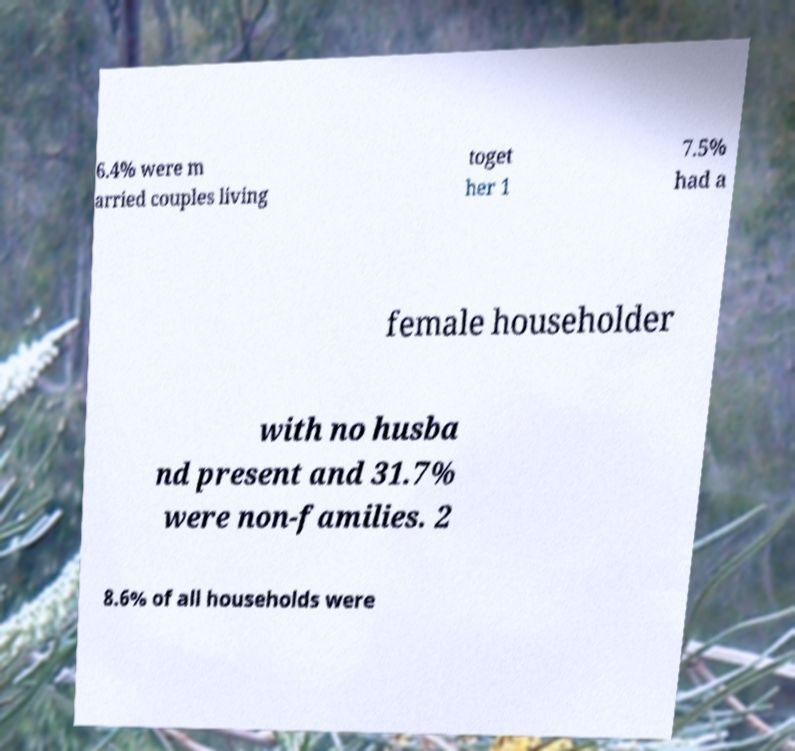Please identify and transcribe the text found in this image. 6.4% were m arried couples living toget her 1 7.5% had a female householder with no husba nd present and 31.7% were non-families. 2 8.6% of all households were 